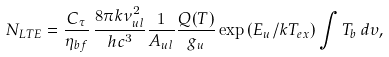<formula> <loc_0><loc_0><loc_500><loc_500>N _ { L T E } = \frac { C _ { \tau } } { \eta _ { b f } } \, \frac { 8 \pi k \nu _ { u l } ^ { 2 } } { h c ^ { 3 } } \frac { 1 } { A _ { u l } } \frac { Q ( T ) } { g _ { u } } \exp \, ( E _ { u } / k T _ { e x } ) \int { T _ { b } } \, d \upsilon ,</formula> 